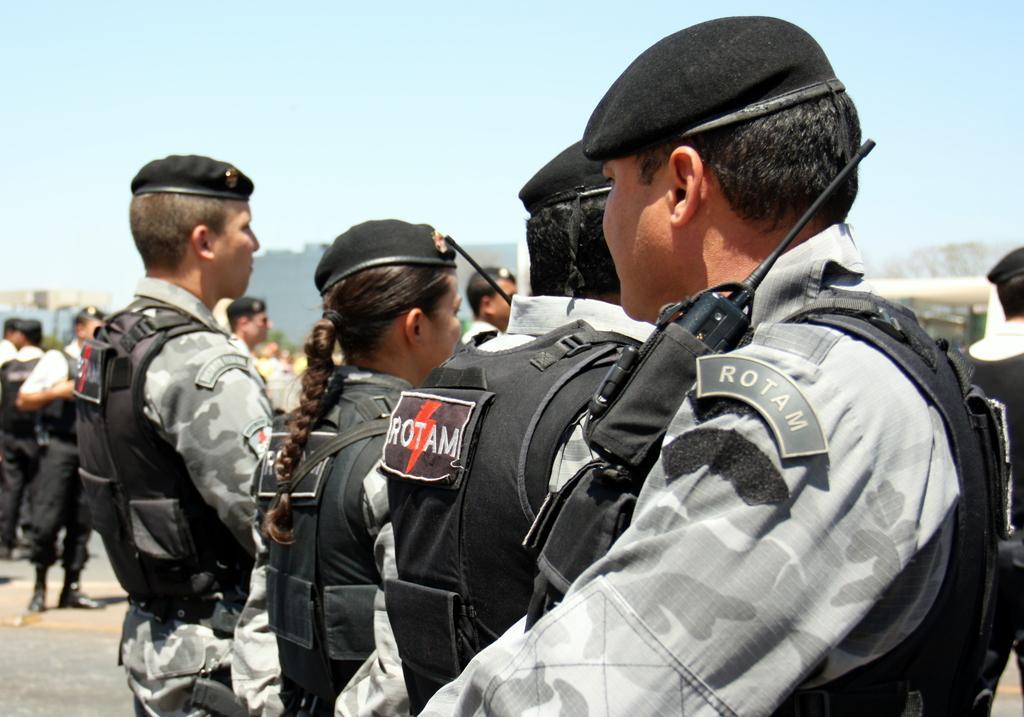Can you describe this image briefly? In the center of the image we can see persons standing on the road. In the background we can see persons, trees, building, hill and sky. 